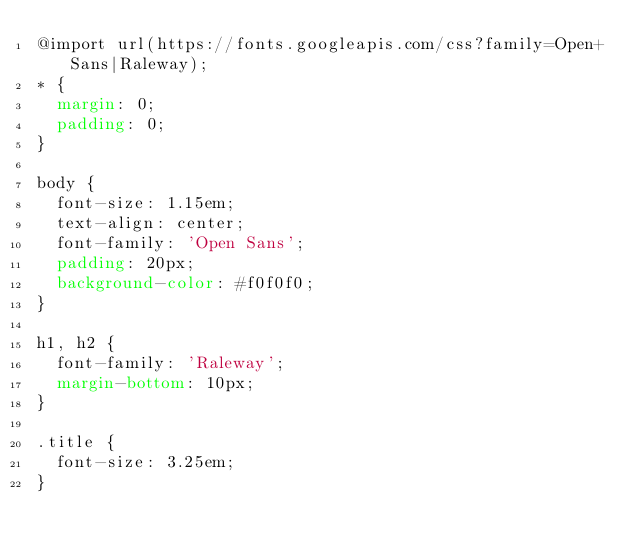<code> <loc_0><loc_0><loc_500><loc_500><_CSS_>@import url(https://fonts.googleapis.com/css?family=Open+Sans|Raleway);
* {
  margin: 0;
  padding: 0;
}

body {
  font-size: 1.15em;
  text-align: center;
  font-family: 'Open Sans';
  padding: 20px;
  background-color: #f0f0f0;
}

h1, h2 {
  font-family: 'Raleway';
  margin-bottom: 10px;
}

.title {
  font-size: 3.25em;
}
</code> 